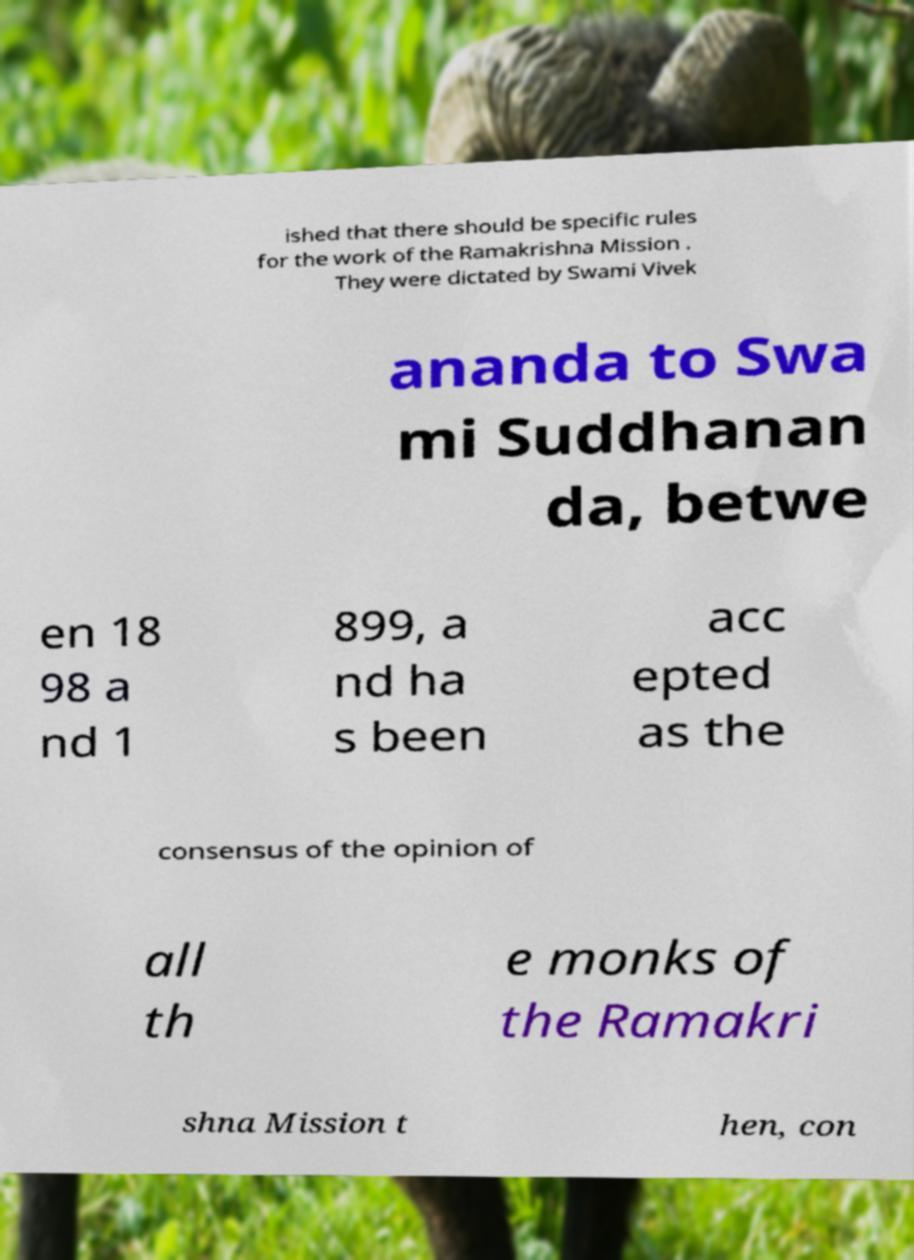For documentation purposes, I need the text within this image transcribed. Could you provide that? ished that there should be specific rules for the work of the Ramakrishna Mission . They were dictated by Swami Vivek ananda to Swa mi Suddhanan da, betwe en 18 98 a nd 1 899, a nd ha s been acc epted as the consensus of the opinion of all th e monks of the Ramakri shna Mission t hen, con 